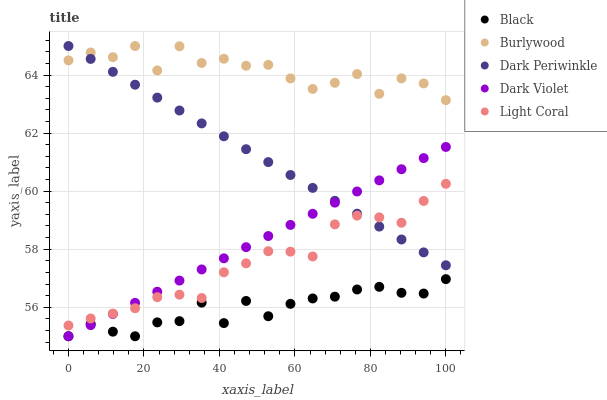Does Black have the minimum area under the curve?
Answer yes or no. Yes. Does Burlywood have the maximum area under the curve?
Answer yes or no. Yes. Does Light Coral have the minimum area under the curve?
Answer yes or no. No. Does Light Coral have the maximum area under the curve?
Answer yes or no. No. Is Dark Violet the smoothest?
Answer yes or no. Yes. Is Burlywood the roughest?
Answer yes or no. Yes. Is Light Coral the smoothest?
Answer yes or no. No. Is Light Coral the roughest?
Answer yes or no. No. Does Black have the lowest value?
Answer yes or no. Yes. Does Light Coral have the lowest value?
Answer yes or no. No. Does Dark Periwinkle have the highest value?
Answer yes or no. Yes. Does Light Coral have the highest value?
Answer yes or no. No. Is Black less than Light Coral?
Answer yes or no. Yes. Is Burlywood greater than Dark Violet?
Answer yes or no. Yes. Does Dark Violet intersect Light Coral?
Answer yes or no. Yes. Is Dark Violet less than Light Coral?
Answer yes or no. No. Is Dark Violet greater than Light Coral?
Answer yes or no. No. Does Black intersect Light Coral?
Answer yes or no. No. 